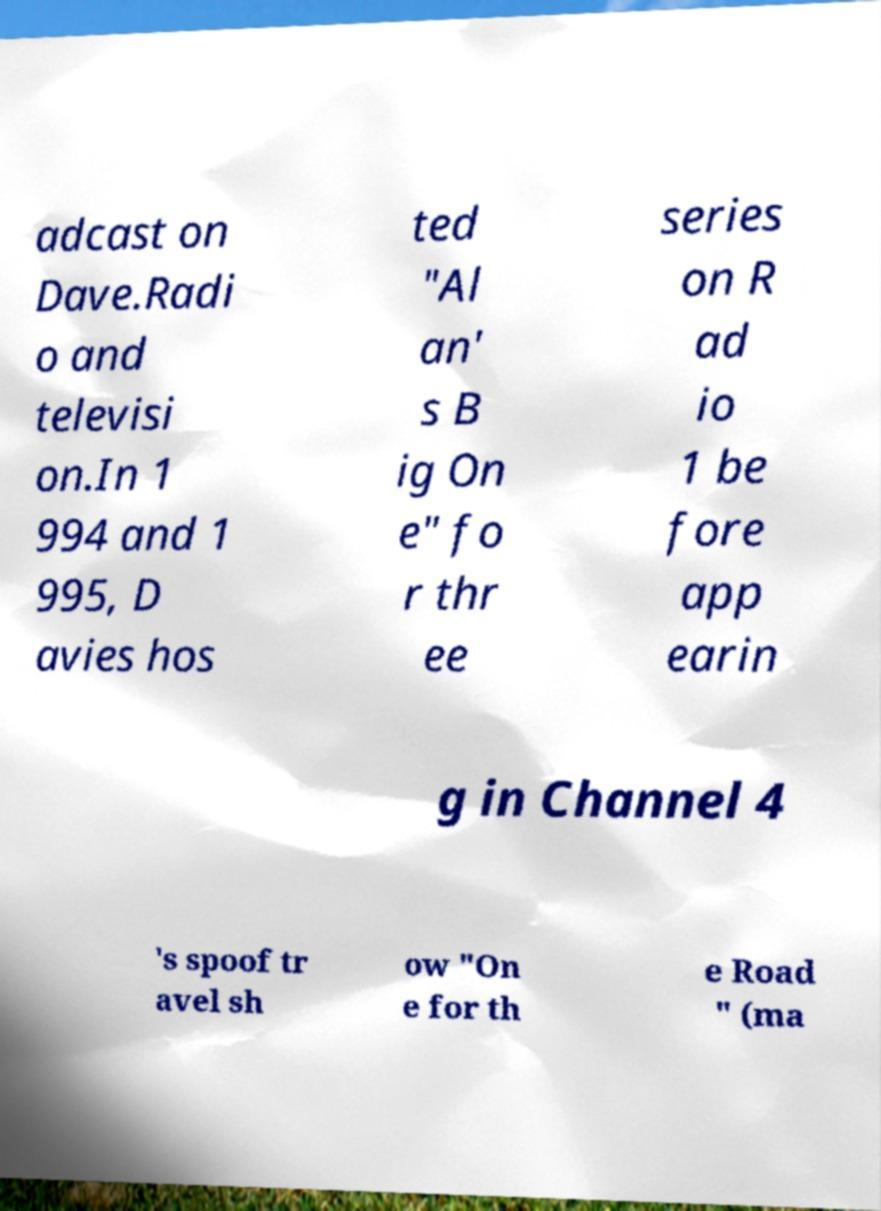For documentation purposes, I need the text within this image transcribed. Could you provide that? adcast on Dave.Radi o and televisi on.In 1 994 and 1 995, D avies hos ted "Al an' s B ig On e" fo r thr ee series on R ad io 1 be fore app earin g in Channel 4 's spoof tr avel sh ow "On e for th e Road " (ma 